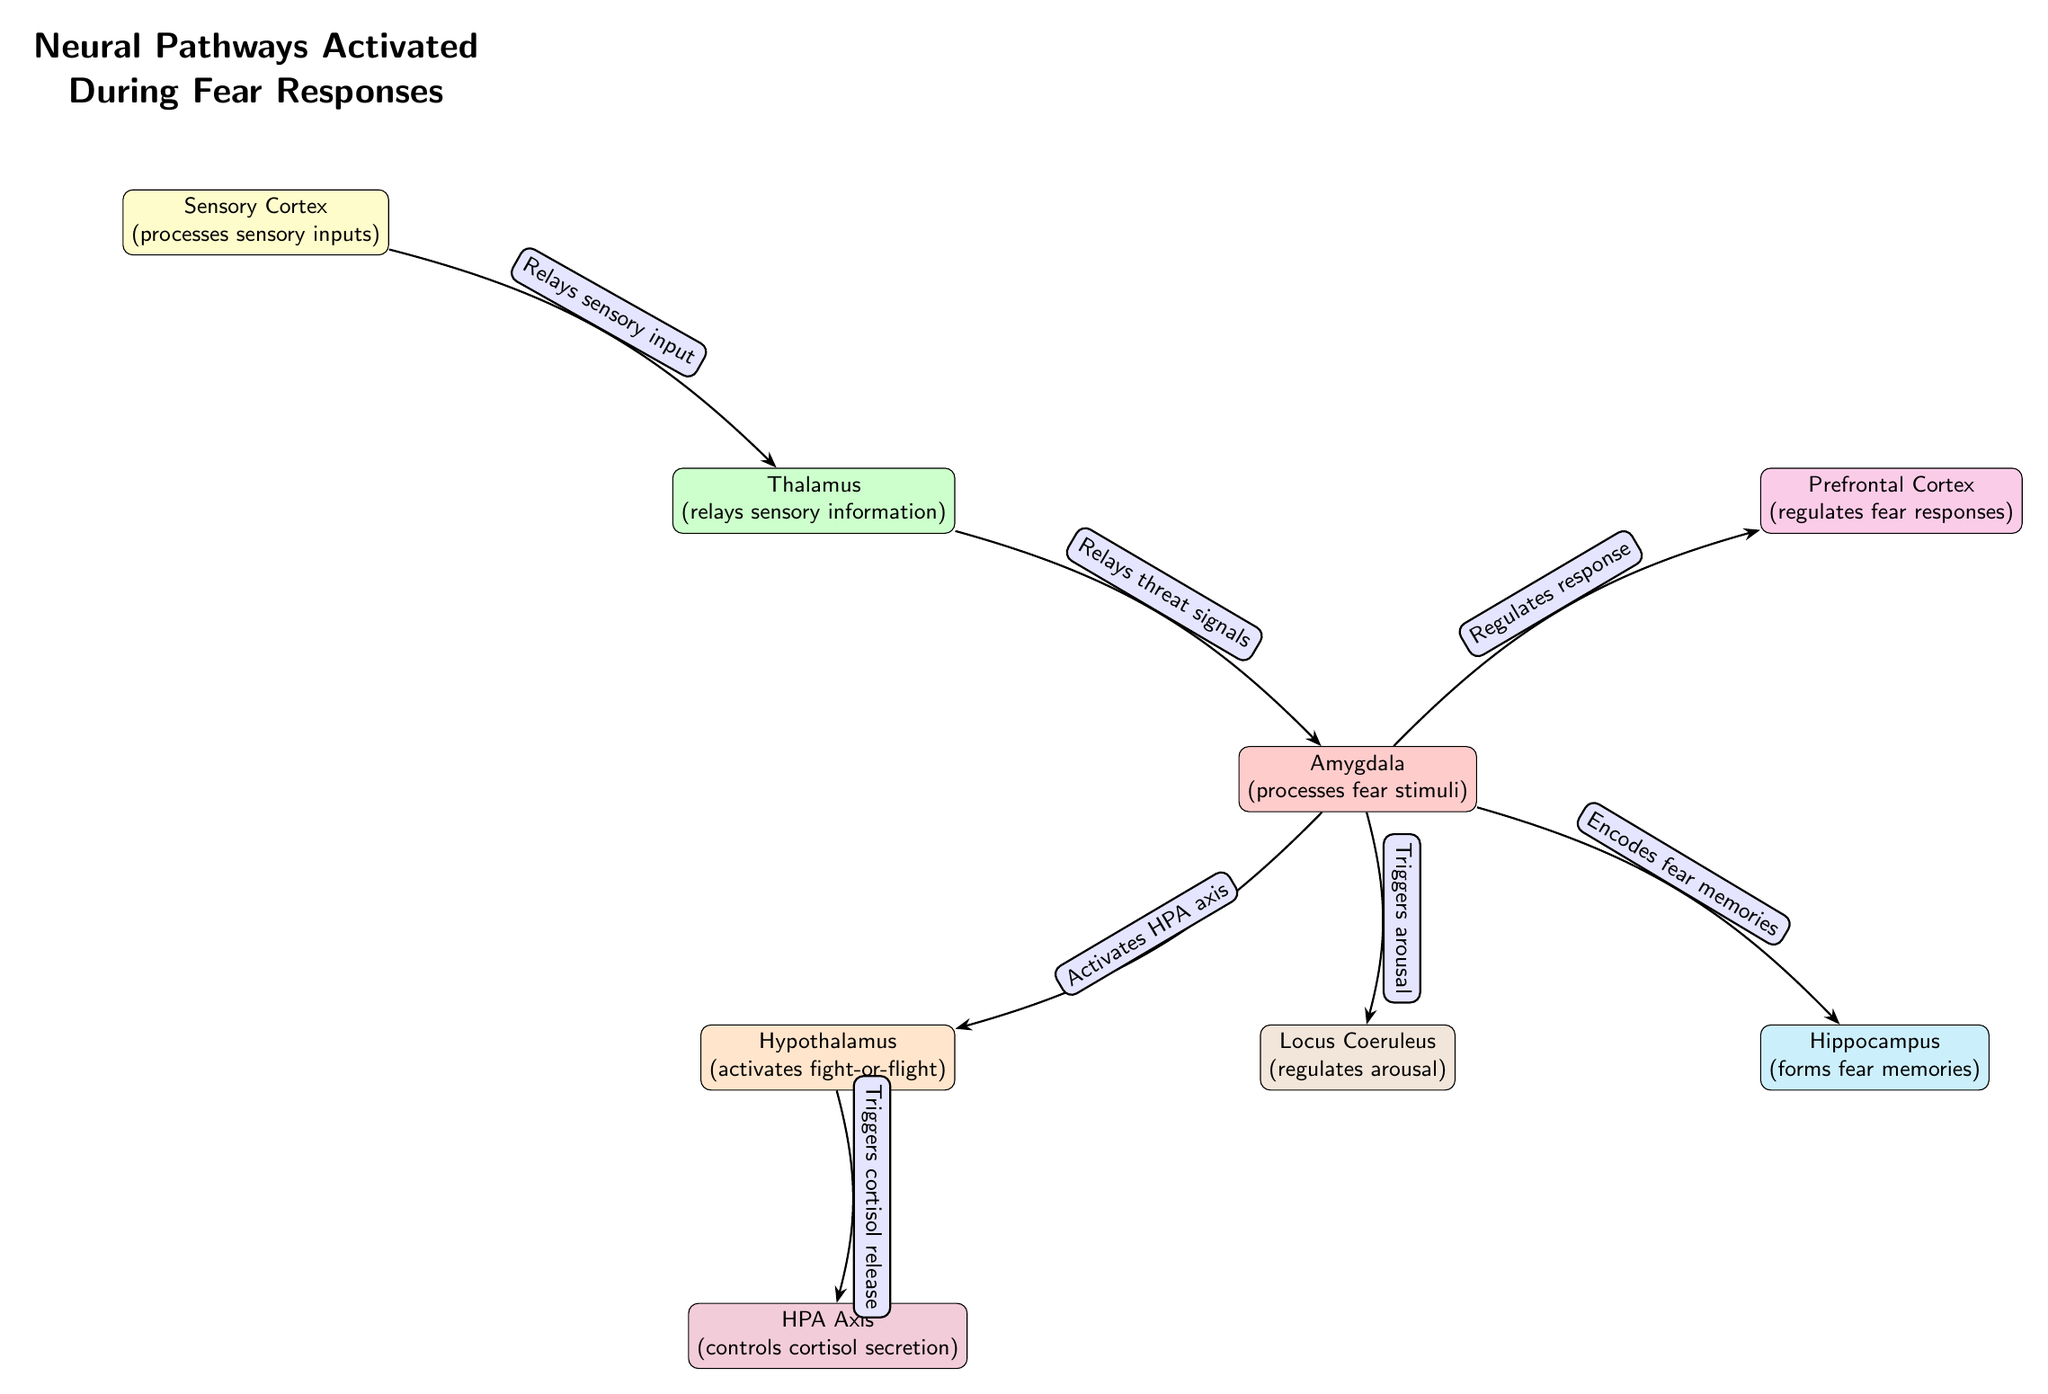What is the first node in the diagram? The first node in the diagram is the Sensory Cortex, which processes sensory inputs. It is positioned at the top and is the starting point for the flow of information in the diagram.
Answer: Sensory Cortex How many total nodes are present in the diagram? By counting the nodes visually in the diagram, I can identify there are eight distinct nodes representing different brain regions involved in fear responses.
Answer: 8 What color is the Amygdala node? The Amygdala node is filled with red color, which helps distinguish it from other nodes in the diagram.
Answer: Red Which node is responsible for regulating fear responses? The Prefrontal Cortex is responsible for regulating fear responses and is indicated in the diagram as connected to the Amygdala node, highlighting its regulatory role.
Answer: Prefrontal Cortex What does the Locus Coeruleus trigger? The Locus Coeruleus triggers arousal, as indicated by the connection from the Amygdala in the diagram, illustrating its role in preparing the body for a response to fear.
Answer: Arousal What is the relationship between the Amygdala and the HPA Axis? The relationship is that the Amygdala activates the HPA Axis, which controls the secretion of cortisol, underlining the role of emotions in physiological responses to fear.
Answer: Activates HPA axis Which node is activated first in response to sensory inputs? The first node activated is the Thalamus, which relays sensory information from the Sensory Cortex to the Amygdala for further processing of fear stimuli.
Answer: Thalamus What role does the Hippocampus play in fear responses? The Hippocampus encodes fear memories, as shown in the diagram through its direct connection to the Amygdala, indicating its involvement in memory formation related to fear.
Answer: Encodes fear memories What triggers cortisol release in the diagram? The Hypothalamus triggers cortisol release, and it's linked to the HPA Axis, indicating a crucial step in the body's stress response system during fear situations.
Answer: Triggers cortisol release 